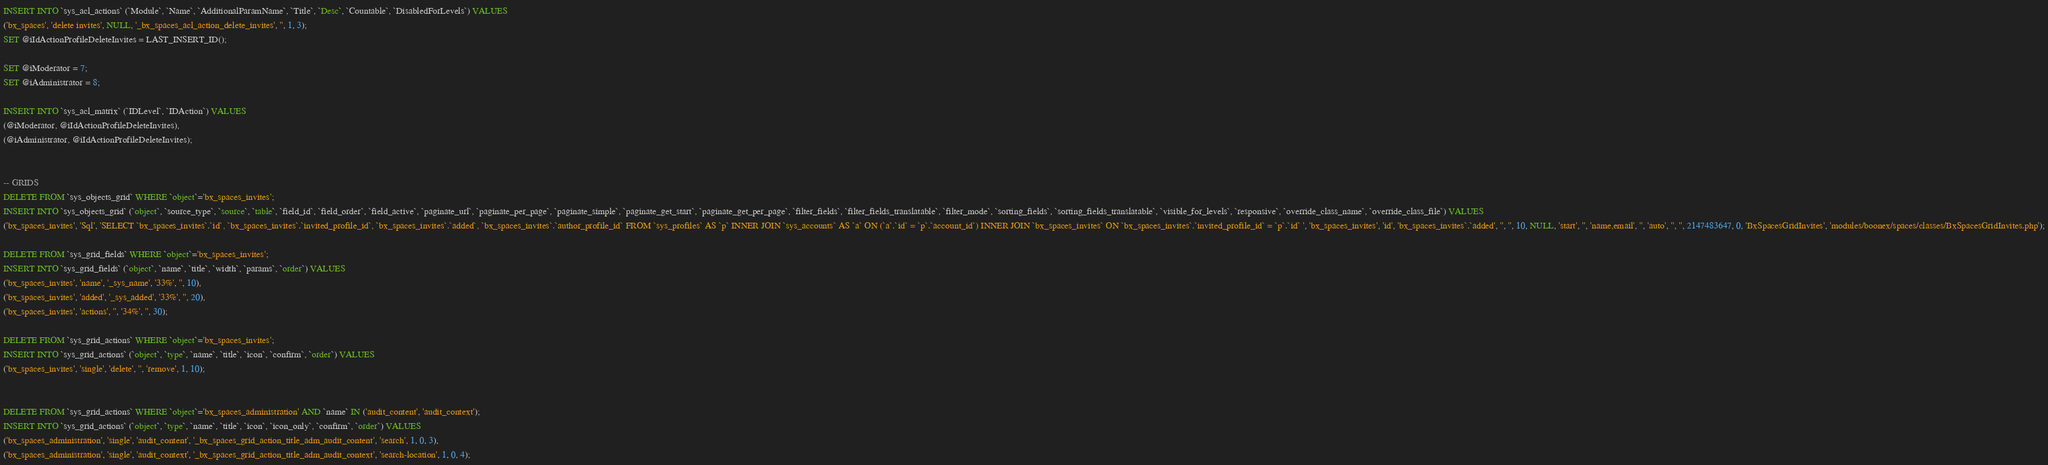Convert code to text. <code><loc_0><loc_0><loc_500><loc_500><_SQL_>
INSERT INTO `sys_acl_actions` (`Module`, `Name`, `AdditionalParamName`, `Title`, `Desc`, `Countable`, `DisabledForLevels`) VALUES
('bx_spaces', 'delete invites', NULL, '_bx_spaces_acl_action_delete_invites', '', 1, 3);
SET @iIdActionProfileDeleteInvites = LAST_INSERT_ID();

SET @iModerator = 7;
SET @iAdministrator = 8;

INSERT INTO `sys_acl_matrix` (`IDLevel`, `IDAction`) VALUES
(@iModerator, @iIdActionProfileDeleteInvites),
(@iAdministrator, @iIdActionProfileDeleteInvites);


-- GRIDS
DELETE FROM `sys_objects_grid` WHERE `object`='bx_spaces_invites';
INSERT INTO `sys_objects_grid` (`object`, `source_type`, `source`, `table`, `field_id`, `field_order`, `field_active`, `paginate_url`, `paginate_per_page`, `paginate_simple`, `paginate_get_start`, `paginate_get_per_page`, `filter_fields`, `filter_fields_translatable`, `filter_mode`, `sorting_fields`, `sorting_fields_translatable`, `visible_for_levels`, `responsive`, `override_class_name`, `override_class_file`) VALUES
('bx_spaces_invites', 'Sql', 'SELECT `bx_spaces_invites`.`id`, `bx_spaces_invites`.`invited_profile_id`, `bx_spaces_invites`.`added`, `bx_spaces_invites`.`author_profile_id` FROM `sys_profiles` AS `p` INNER JOIN `sys_accounts` AS `a` ON (`a`.`id` = `p`.`account_id`) INNER JOIN `bx_spaces_invites` ON `bx_spaces_invites`.`invited_profile_id` = `p`.`id` ', 'bx_spaces_invites', 'id', 'bx_spaces_invites`.`added', '', '', 10, NULL, 'start', '', 'name,email', '', 'auto', '', '', 2147483647, 0, 'BxSpacesGridInvites', 'modules/boonex/spaces/classes/BxSpacesGridInvites.php');

DELETE FROM `sys_grid_fields` WHERE `object`='bx_spaces_invites';
INSERT INTO `sys_grid_fields` (`object`, `name`, `title`, `width`, `params`, `order`) VALUES
('bx_spaces_invites', 'name', '_sys_name', '33%', '', 10),
('bx_spaces_invites', 'added', '_sys_added', '33%', '', 20),
('bx_spaces_invites', 'actions', '', '34%', '', 30);

DELETE FROM `sys_grid_actions` WHERE `object`='bx_spaces_invites';
INSERT INTO `sys_grid_actions` (`object`, `type`, `name`, `title`, `icon`, `confirm`, `order`) VALUES
('bx_spaces_invites', 'single', 'delete', '', 'remove', 1, 10);


DELETE FROM `sys_grid_actions` WHERE `object`='bx_spaces_administration' AND `name` IN ('audit_content', 'audit_context');
INSERT INTO `sys_grid_actions` (`object`, `type`, `name`, `title`, `icon`, `icon_only`, `confirm`, `order`) VALUES
('bx_spaces_administration', 'single', 'audit_content', '_bx_spaces_grid_action_title_adm_audit_content', 'search', 1, 0, 3),
('bx_spaces_administration', 'single', 'audit_context', '_bx_spaces_grid_action_title_adm_audit_context', 'search-location', 1, 0, 4);
</code> 